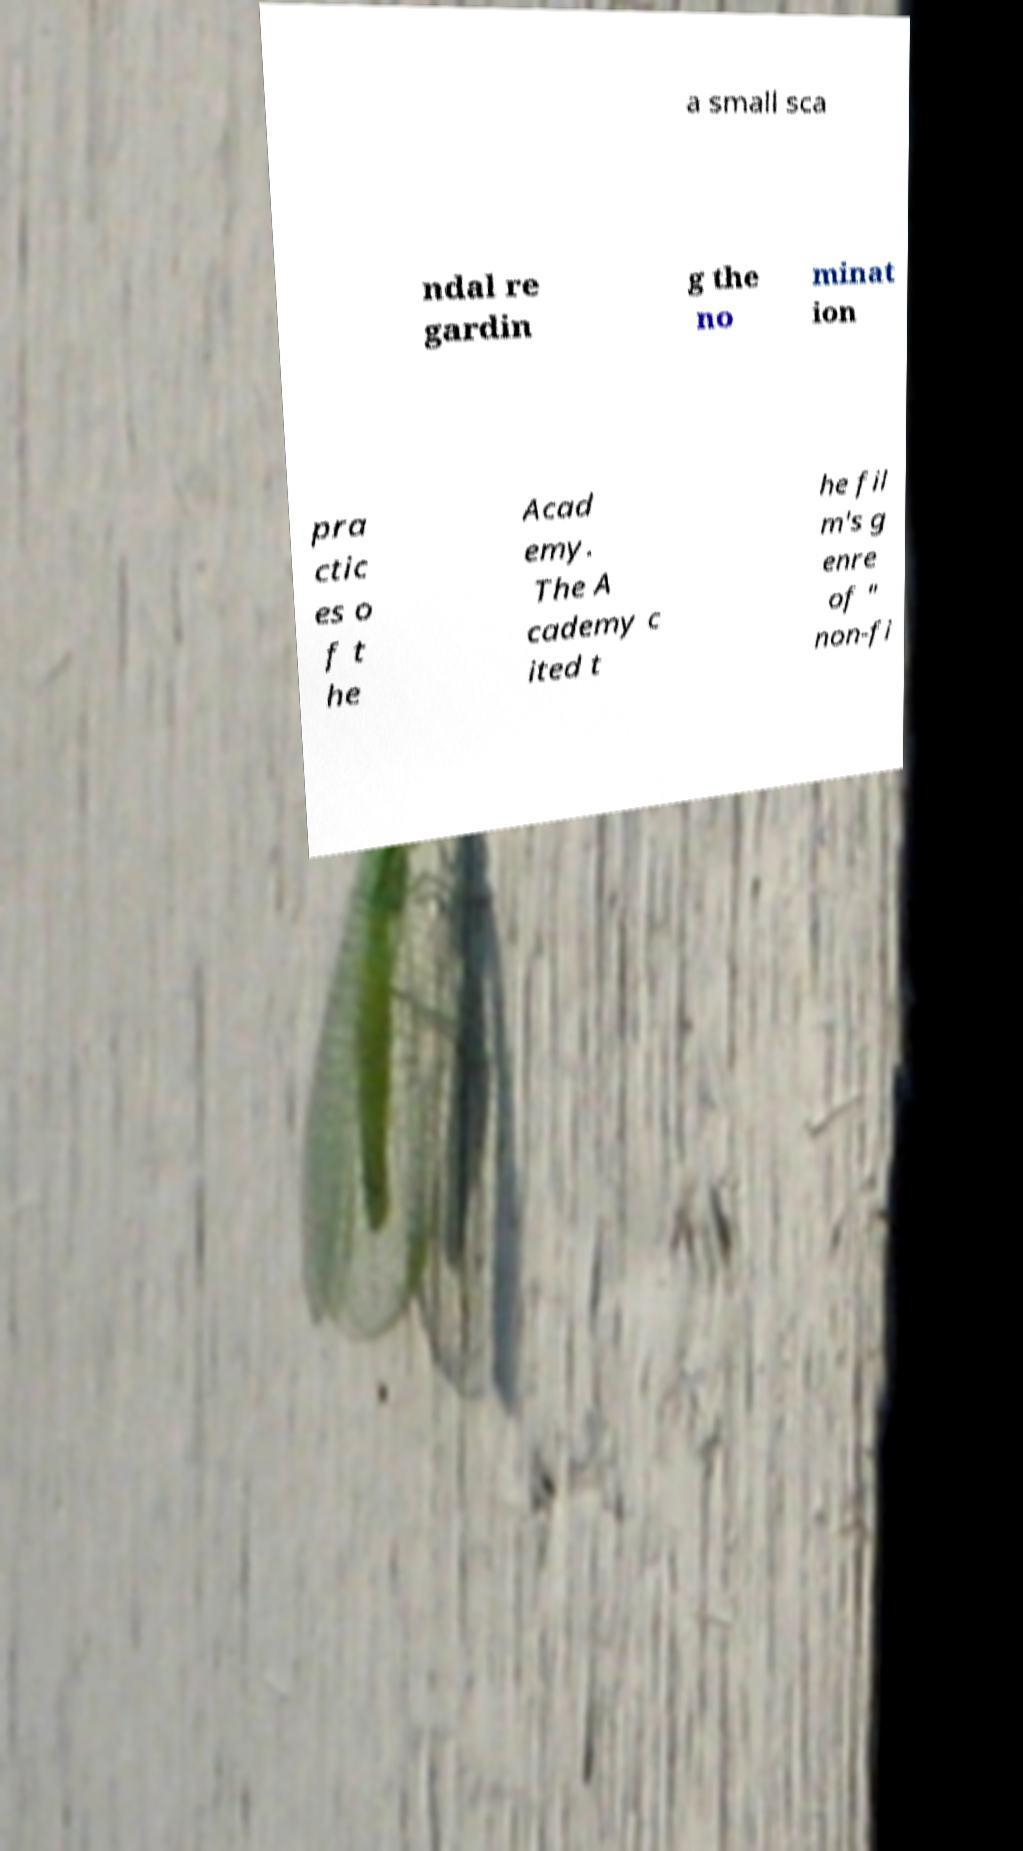Can you read and provide the text displayed in the image?This photo seems to have some interesting text. Can you extract and type it out for me? a small sca ndal re gardin g the no minat ion pra ctic es o f t he Acad emy. The A cademy c ited t he fil m's g enre of " non-fi 